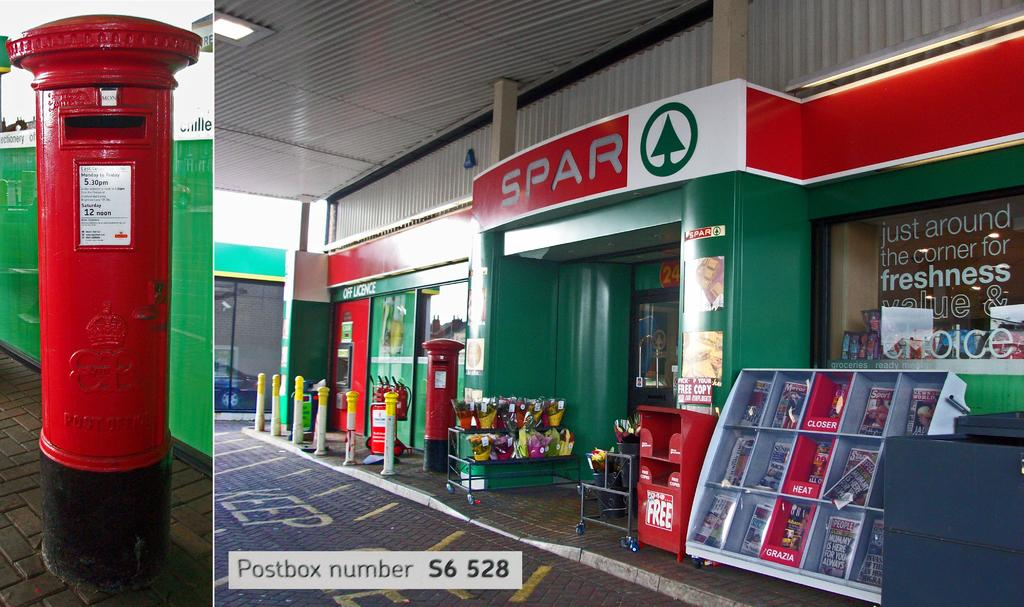<image>
Present a compact description of the photo's key features. The green and red store front for Spar with bollards and items outside. 